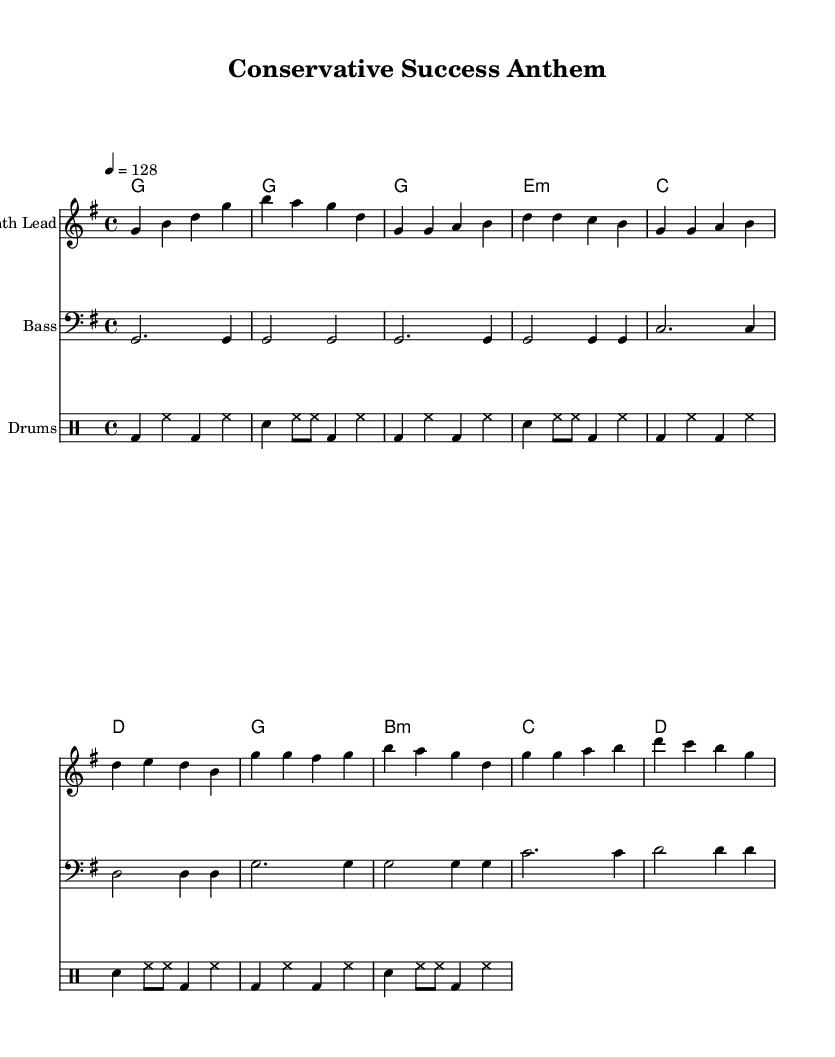What is the key signature of this music? The key signature is G major, which has one sharp (F#). The presence of the F# in the melody confirms this.
Answer: G major What is the time signature of this piece? The time signature is indicated as 4/4, meaning there are four beats per measure, and the quarter note gets one beat. This is visible at the beginning of the sheet music.
Answer: 4/4 What is the tempo marking for this composition? The tempo is marked as 128 beats per minute, which determines the speed of the music. This information is provided within the tempo directive at the start.
Answer: 128 How many measures are there in the chorus section? The chorus section contains four measures; this can be determined by counting the measures outlined under the 'Chorus' label in the sheet music.
Answer: 4 What instruments are included in this score? The score includes a Synth Lead, Bass, and Drums, as indicated by the titles of the respective staves in the rendered sheet music.
Answer: Synth Lead, Bass, Drums Which chord is used in the first measure? The first measure features a G major chord, which is confirmed by the chord names on the score.
Answer: G major 